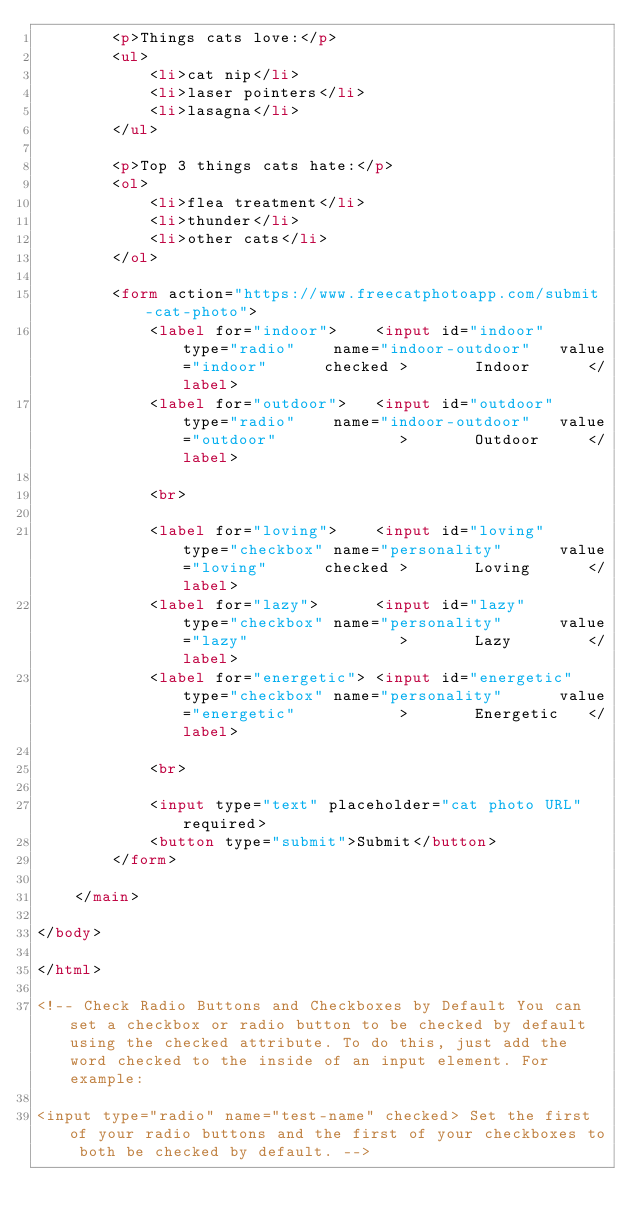Convert code to text. <code><loc_0><loc_0><loc_500><loc_500><_HTML_>        <p>Things cats love:</p>
        <ul>
            <li>cat nip</li>
            <li>laser pointers</li>
            <li>lasagna</li>
        </ul>

        <p>Top 3 things cats hate:</p>
        <ol>
            <li>flea treatment</li>
            <li>thunder</li>
            <li>other cats</li>
        </ol>

        <form action="https://www.freecatphotoapp.com/submit-cat-photo">
            <label for="indoor">    <input id="indoor"      type="radio"    name="indoor-outdoor"   value="indoor"      checked >       Indoor      </label>
            <label for="outdoor">   <input id="outdoor"     type="radio"    name="indoor-outdoor"   value="outdoor"             >       Outdoor     </label>

            <br>

            <label for="loving">    <input id="loving"      type="checkbox" name="personality"      value="loving"      checked >       Loving      </label>
            <label for="lazy">      <input id="lazy"        type="checkbox" name="personality"      value="lazy"                >       Lazy        </label>
            <label for="energetic"> <input id="energetic"   type="checkbox" name="personality"      value="energetic"           >       Energetic   </label>

            <br>

            <input type="text" placeholder="cat photo URL" required>
            <button type="submit">Submit</button>
        </form>

    </main>

</body>

</html>

<!-- Check Radio Buttons and Checkboxes by Default You can set a checkbox or radio button to be checked by default using the checked attribute. To do this, just add the word checked to the inside of an input element. For example:

<input type="radio" name="test-name" checked> Set the first of your radio buttons and the first of your checkboxes to both be checked by default. --></code> 